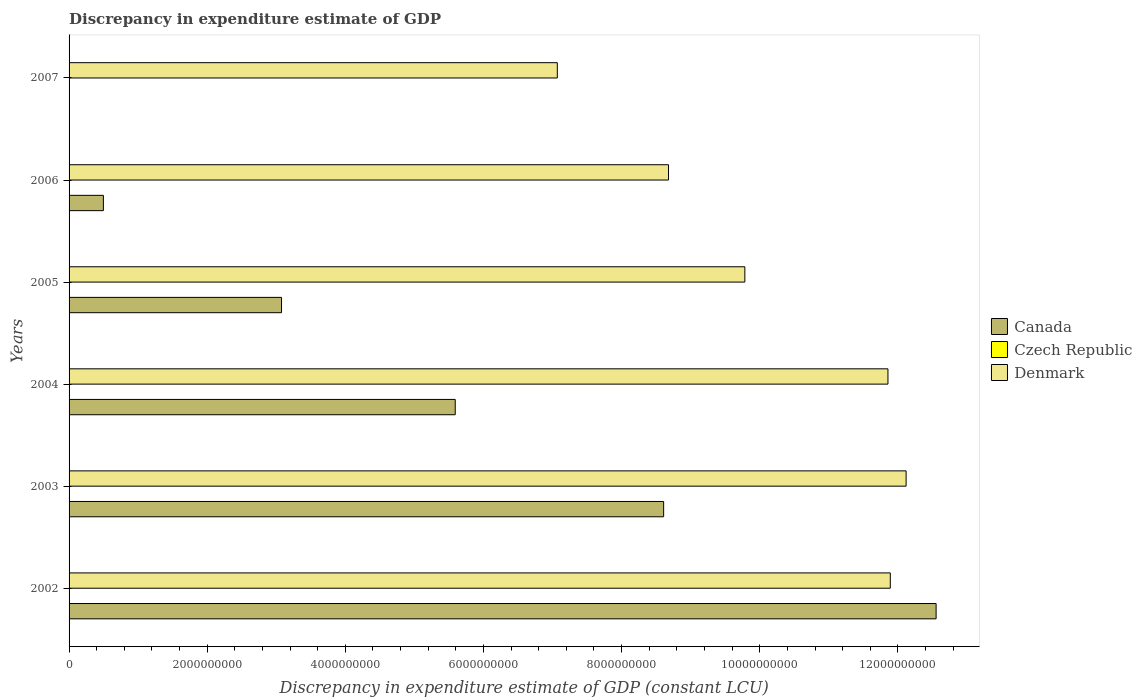Are the number of bars per tick equal to the number of legend labels?
Your answer should be compact. No. Are the number of bars on each tick of the Y-axis equal?
Ensure brevity in your answer.  No. How many bars are there on the 1st tick from the top?
Offer a very short reply. 1. What is the label of the 2nd group of bars from the top?
Provide a short and direct response. 2006. In how many cases, is the number of bars for a given year not equal to the number of legend labels?
Your response must be concise. 6. What is the discrepancy in expenditure estimate of GDP in Denmark in 2007?
Make the answer very short. 7.07e+09. Across all years, what is the maximum discrepancy in expenditure estimate of GDP in Denmark?
Provide a succinct answer. 1.21e+1. Across all years, what is the minimum discrepancy in expenditure estimate of GDP in Denmark?
Keep it short and to the point. 7.07e+09. What is the total discrepancy in expenditure estimate of GDP in Denmark in the graph?
Ensure brevity in your answer.  6.14e+1. What is the difference between the discrepancy in expenditure estimate of GDP in Canada in 2004 and that in 2005?
Your response must be concise. 2.51e+09. What is the difference between the discrepancy in expenditure estimate of GDP in Canada in 2006 and the discrepancy in expenditure estimate of GDP in Czech Republic in 2007?
Keep it short and to the point. 4.97e+08. In the year 2002, what is the difference between the discrepancy in expenditure estimate of GDP in Denmark and discrepancy in expenditure estimate of GDP in Canada?
Ensure brevity in your answer.  -6.63e+08. In how many years, is the discrepancy in expenditure estimate of GDP in Canada greater than 2000000000 LCU?
Your answer should be very brief. 4. What is the ratio of the discrepancy in expenditure estimate of GDP in Denmark in 2003 to that in 2004?
Provide a short and direct response. 1.02. Is the difference between the discrepancy in expenditure estimate of GDP in Denmark in 2002 and 2006 greater than the difference between the discrepancy in expenditure estimate of GDP in Canada in 2002 and 2006?
Provide a short and direct response. No. What is the difference between the highest and the second highest discrepancy in expenditure estimate of GDP in Denmark?
Keep it short and to the point. 2.29e+08. What is the difference between the highest and the lowest discrepancy in expenditure estimate of GDP in Canada?
Ensure brevity in your answer.  1.26e+1. Is it the case that in every year, the sum of the discrepancy in expenditure estimate of GDP in Denmark and discrepancy in expenditure estimate of GDP in Canada is greater than the discrepancy in expenditure estimate of GDP in Czech Republic?
Your answer should be very brief. Yes. How many bars are there?
Provide a short and direct response. 11. How many years are there in the graph?
Provide a succinct answer. 6. What is the difference between two consecutive major ticks on the X-axis?
Offer a terse response. 2.00e+09. Are the values on the major ticks of X-axis written in scientific E-notation?
Provide a succinct answer. No. Does the graph contain any zero values?
Ensure brevity in your answer.  Yes. Where does the legend appear in the graph?
Your answer should be compact. Center right. How many legend labels are there?
Give a very brief answer. 3. What is the title of the graph?
Your answer should be very brief. Discrepancy in expenditure estimate of GDP. Does "Afghanistan" appear as one of the legend labels in the graph?
Provide a succinct answer. No. What is the label or title of the X-axis?
Give a very brief answer. Discrepancy in expenditure estimate of GDP (constant LCU). What is the Discrepancy in expenditure estimate of GDP (constant LCU) of Canada in 2002?
Your answer should be compact. 1.26e+1. What is the Discrepancy in expenditure estimate of GDP (constant LCU) of Czech Republic in 2002?
Your answer should be very brief. 0. What is the Discrepancy in expenditure estimate of GDP (constant LCU) in Denmark in 2002?
Provide a succinct answer. 1.19e+1. What is the Discrepancy in expenditure estimate of GDP (constant LCU) in Canada in 2003?
Provide a short and direct response. 8.61e+09. What is the Discrepancy in expenditure estimate of GDP (constant LCU) in Denmark in 2003?
Offer a very short reply. 1.21e+1. What is the Discrepancy in expenditure estimate of GDP (constant LCU) in Canada in 2004?
Your response must be concise. 5.59e+09. What is the Discrepancy in expenditure estimate of GDP (constant LCU) of Denmark in 2004?
Offer a very short reply. 1.19e+1. What is the Discrepancy in expenditure estimate of GDP (constant LCU) in Canada in 2005?
Provide a short and direct response. 3.08e+09. What is the Discrepancy in expenditure estimate of GDP (constant LCU) in Denmark in 2005?
Your response must be concise. 9.78e+09. What is the Discrepancy in expenditure estimate of GDP (constant LCU) in Canada in 2006?
Offer a very short reply. 4.97e+08. What is the Discrepancy in expenditure estimate of GDP (constant LCU) of Czech Republic in 2006?
Offer a very short reply. 0. What is the Discrepancy in expenditure estimate of GDP (constant LCU) in Denmark in 2006?
Provide a short and direct response. 8.68e+09. What is the Discrepancy in expenditure estimate of GDP (constant LCU) of Canada in 2007?
Offer a terse response. 0. What is the Discrepancy in expenditure estimate of GDP (constant LCU) in Denmark in 2007?
Ensure brevity in your answer.  7.07e+09. Across all years, what is the maximum Discrepancy in expenditure estimate of GDP (constant LCU) of Canada?
Provide a succinct answer. 1.26e+1. Across all years, what is the maximum Discrepancy in expenditure estimate of GDP (constant LCU) of Denmark?
Give a very brief answer. 1.21e+1. Across all years, what is the minimum Discrepancy in expenditure estimate of GDP (constant LCU) in Canada?
Your answer should be very brief. 0. Across all years, what is the minimum Discrepancy in expenditure estimate of GDP (constant LCU) of Denmark?
Offer a very short reply. 7.07e+09. What is the total Discrepancy in expenditure estimate of GDP (constant LCU) of Canada in the graph?
Provide a succinct answer. 3.03e+1. What is the total Discrepancy in expenditure estimate of GDP (constant LCU) of Czech Republic in the graph?
Give a very brief answer. 0. What is the total Discrepancy in expenditure estimate of GDP (constant LCU) in Denmark in the graph?
Make the answer very short. 6.14e+1. What is the difference between the Discrepancy in expenditure estimate of GDP (constant LCU) of Canada in 2002 and that in 2003?
Make the answer very short. 3.94e+09. What is the difference between the Discrepancy in expenditure estimate of GDP (constant LCU) of Denmark in 2002 and that in 2003?
Ensure brevity in your answer.  -2.29e+08. What is the difference between the Discrepancy in expenditure estimate of GDP (constant LCU) of Canada in 2002 and that in 2004?
Make the answer very short. 6.96e+09. What is the difference between the Discrepancy in expenditure estimate of GDP (constant LCU) in Denmark in 2002 and that in 2004?
Keep it short and to the point. 3.40e+07. What is the difference between the Discrepancy in expenditure estimate of GDP (constant LCU) of Canada in 2002 and that in 2005?
Give a very brief answer. 9.48e+09. What is the difference between the Discrepancy in expenditure estimate of GDP (constant LCU) of Denmark in 2002 and that in 2005?
Your response must be concise. 2.11e+09. What is the difference between the Discrepancy in expenditure estimate of GDP (constant LCU) in Canada in 2002 and that in 2006?
Make the answer very short. 1.21e+1. What is the difference between the Discrepancy in expenditure estimate of GDP (constant LCU) in Denmark in 2002 and that in 2006?
Your answer should be compact. 3.21e+09. What is the difference between the Discrepancy in expenditure estimate of GDP (constant LCU) of Denmark in 2002 and that in 2007?
Your answer should be very brief. 4.82e+09. What is the difference between the Discrepancy in expenditure estimate of GDP (constant LCU) in Canada in 2003 and that in 2004?
Make the answer very short. 3.02e+09. What is the difference between the Discrepancy in expenditure estimate of GDP (constant LCU) in Denmark in 2003 and that in 2004?
Provide a short and direct response. 2.63e+08. What is the difference between the Discrepancy in expenditure estimate of GDP (constant LCU) in Canada in 2003 and that in 2005?
Ensure brevity in your answer.  5.53e+09. What is the difference between the Discrepancy in expenditure estimate of GDP (constant LCU) of Denmark in 2003 and that in 2005?
Your answer should be very brief. 2.34e+09. What is the difference between the Discrepancy in expenditure estimate of GDP (constant LCU) of Canada in 2003 and that in 2006?
Ensure brevity in your answer.  8.11e+09. What is the difference between the Discrepancy in expenditure estimate of GDP (constant LCU) in Denmark in 2003 and that in 2006?
Ensure brevity in your answer.  3.44e+09. What is the difference between the Discrepancy in expenditure estimate of GDP (constant LCU) of Denmark in 2003 and that in 2007?
Give a very brief answer. 5.05e+09. What is the difference between the Discrepancy in expenditure estimate of GDP (constant LCU) of Canada in 2004 and that in 2005?
Keep it short and to the point. 2.51e+09. What is the difference between the Discrepancy in expenditure estimate of GDP (constant LCU) of Denmark in 2004 and that in 2005?
Your answer should be compact. 2.07e+09. What is the difference between the Discrepancy in expenditure estimate of GDP (constant LCU) in Canada in 2004 and that in 2006?
Offer a very short reply. 5.09e+09. What is the difference between the Discrepancy in expenditure estimate of GDP (constant LCU) of Denmark in 2004 and that in 2006?
Keep it short and to the point. 3.18e+09. What is the difference between the Discrepancy in expenditure estimate of GDP (constant LCU) in Denmark in 2004 and that in 2007?
Provide a short and direct response. 4.79e+09. What is the difference between the Discrepancy in expenditure estimate of GDP (constant LCU) in Canada in 2005 and that in 2006?
Your answer should be very brief. 2.58e+09. What is the difference between the Discrepancy in expenditure estimate of GDP (constant LCU) in Denmark in 2005 and that in 2006?
Ensure brevity in your answer.  1.10e+09. What is the difference between the Discrepancy in expenditure estimate of GDP (constant LCU) of Denmark in 2005 and that in 2007?
Ensure brevity in your answer.  2.72e+09. What is the difference between the Discrepancy in expenditure estimate of GDP (constant LCU) of Denmark in 2006 and that in 2007?
Provide a succinct answer. 1.61e+09. What is the difference between the Discrepancy in expenditure estimate of GDP (constant LCU) in Canada in 2002 and the Discrepancy in expenditure estimate of GDP (constant LCU) in Denmark in 2003?
Offer a very short reply. 4.34e+08. What is the difference between the Discrepancy in expenditure estimate of GDP (constant LCU) of Canada in 2002 and the Discrepancy in expenditure estimate of GDP (constant LCU) of Denmark in 2004?
Keep it short and to the point. 6.97e+08. What is the difference between the Discrepancy in expenditure estimate of GDP (constant LCU) in Canada in 2002 and the Discrepancy in expenditure estimate of GDP (constant LCU) in Denmark in 2005?
Offer a very short reply. 2.77e+09. What is the difference between the Discrepancy in expenditure estimate of GDP (constant LCU) of Canada in 2002 and the Discrepancy in expenditure estimate of GDP (constant LCU) of Denmark in 2006?
Your answer should be compact. 3.87e+09. What is the difference between the Discrepancy in expenditure estimate of GDP (constant LCU) in Canada in 2002 and the Discrepancy in expenditure estimate of GDP (constant LCU) in Denmark in 2007?
Offer a terse response. 5.48e+09. What is the difference between the Discrepancy in expenditure estimate of GDP (constant LCU) of Canada in 2003 and the Discrepancy in expenditure estimate of GDP (constant LCU) of Denmark in 2004?
Offer a terse response. -3.25e+09. What is the difference between the Discrepancy in expenditure estimate of GDP (constant LCU) of Canada in 2003 and the Discrepancy in expenditure estimate of GDP (constant LCU) of Denmark in 2005?
Your response must be concise. -1.18e+09. What is the difference between the Discrepancy in expenditure estimate of GDP (constant LCU) of Canada in 2003 and the Discrepancy in expenditure estimate of GDP (constant LCU) of Denmark in 2006?
Ensure brevity in your answer.  -7.06e+07. What is the difference between the Discrepancy in expenditure estimate of GDP (constant LCU) in Canada in 2003 and the Discrepancy in expenditure estimate of GDP (constant LCU) in Denmark in 2007?
Make the answer very short. 1.54e+09. What is the difference between the Discrepancy in expenditure estimate of GDP (constant LCU) in Canada in 2004 and the Discrepancy in expenditure estimate of GDP (constant LCU) in Denmark in 2005?
Provide a short and direct response. -4.19e+09. What is the difference between the Discrepancy in expenditure estimate of GDP (constant LCU) of Canada in 2004 and the Discrepancy in expenditure estimate of GDP (constant LCU) of Denmark in 2006?
Give a very brief answer. -3.09e+09. What is the difference between the Discrepancy in expenditure estimate of GDP (constant LCU) of Canada in 2004 and the Discrepancy in expenditure estimate of GDP (constant LCU) of Denmark in 2007?
Make the answer very short. -1.48e+09. What is the difference between the Discrepancy in expenditure estimate of GDP (constant LCU) in Canada in 2005 and the Discrepancy in expenditure estimate of GDP (constant LCU) in Denmark in 2006?
Ensure brevity in your answer.  -5.60e+09. What is the difference between the Discrepancy in expenditure estimate of GDP (constant LCU) in Canada in 2005 and the Discrepancy in expenditure estimate of GDP (constant LCU) in Denmark in 2007?
Ensure brevity in your answer.  -3.99e+09. What is the difference between the Discrepancy in expenditure estimate of GDP (constant LCU) in Canada in 2006 and the Discrepancy in expenditure estimate of GDP (constant LCU) in Denmark in 2007?
Give a very brief answer. -6.57e+09. What is the average Discrepancy in expenditure estimate of GDP (constant LCU) of Canada per year?
Ensure brevity in your answer.  5.05e+09. What is the average Discrepancy in expenditure estimate of GDP (constant LCU) in Czech Republic per year?
Your answer should be compact. 0. What is the average Discrepancy in expenditure estimate of GDP (constant LCU) in Denmark per year?
Provide a short and direct response. 1.02e+1. In the year 2002, what is the difference between the Discrepancy in expenditure estimate of GDP (constant LCU) in Canada and Discrepancy in expenditure estimate of GDP (constant LCU) in Denmark?
Provide a short and direct response. 6.63e+08. In the year 2003, what is the difference between the Discrepancy in expenditure estimate of GDP (constant LCU) of Canada and Discrepancy in expenditure estimate of GDP (constant LCU) of Denmark?
Your response must be concise. -3.51e+09. In the year 2004, what is the difference between the Discrepancy in expenditure estimate of GDP (constant LCU) of Canada and Discrepancy in expenditure estimate of GDP (constant LCU) of Denmark?
Provide a short and direct response. -6.27e+09. In the year 2005, what is the difference between the Discrepancy in expenditure estimate of GDP (constant LCU) in Canada and Discrepancy in expenditure estimate of GDP (constant LCU) in Denmark?
Offer a very short reply. -6.71e+09. In the year 2006, what is the difference between the Discrepancy in expenditure estimate of GDP (constant LCU) in Canada and Discrepancy in expenditure estimate of GDP (constant LCU) in Denmark?
Your response must be concise. -8.18e+09. What is the ratio of the Discrepancy in expenditure estimate of GDP (constant LCU) in Canada in 2002 to that in 2003?
Ensure brevity in your answer.  1.46. What is the ratio of the Discrepancy in expenditure estimate of GDP (constant LCU) of Denmark in 2002 to that in 2003?
Make the answer very short. 0.98. What is the ratio of the Discrepancy in expenditure estimate of GDP (constant LCU) in Canada in 2002 to that in 2004?
Your answer should be very brief. 2.25. What is the ratio of the Discrepancy in expenditure estimate of GDP (constant LCU) of Denmark in 2002 to that in 2004?
Ensure brevity in your answer.  1. What is the ratio of the Discrepancy in expenditure estimate of GDP (constant LCU) of Canada in 2002 to that in 2005?
Ensure brevity in your answer.  4.08. What is the ratio of the Discrepancy in expenditure estimate of GDP (constant LCU) of Denmark in 2002 to that in 2005?
Your response must be concise. 1.22. What is the ratio of the Discrepancy in expenditure estimate of GDP (constant LCU) in Canada in 2002 to that in 2006?
Provide a short and direct response. 25.26. What is the ratio of the Discrepancy in expenditure estimate of GDP (constant LCU) of Denmark in 2002 to that in 2006?
Provide a succinct answer. 1.37. What is the ratio of the Discrepancy in expenditure estimate of GDP (constant LCU) of Denmark in 2002 to that in 2007?
Offer a terse response. 1.68. What is the ratio of the Discrepancy in expenditure estimate of GDP (constant LCU) of Canada in 2003 to that in 2004?
Keep it short and to the point. 1.54. What is the ratio of the Discrepancy in expenditure estimate of GDP (constant LCU) of Denmark in 2003 to that in 2004?
Provide a short and direct response. 1.02. What is the ratio of the Discrepancy in expenditure estimate of GDP (constant LCU) of Canada in 2003 to that in 2005?
Your answer should be compact. 2.8. What is the ratio of the Discrepancy in expenditure estimate of GDP (constant LCU) of Denmark in 2003 to that in 2005?
Offer a terse response. 1.24. What is the ratio of the Discrepancy in expenditure estimate of GDP (constant LCU) in Canada in 2003 to that in 2006?
Offer a very short reply. 17.32. What is the ratio of the Discrepancy in expenditure estimate of GDP (constant LCU) of Denmark in 2003 to that in 2006?
Ensure brevity in your answer.  1.4. What is the ratio of the Discrepancy in expenditure estimate of GDP (constant LCU) of Denmark in 2003 to that in 2007?
Your response must be concise. 1.71. What is the ratio of the Discrepancy in expenditure estimate of GDP (constant LCU) of Canada in 2004 to that in 2005?
Offer a very short reply. 1.82. What is the ratio of the Discrepancy in expenditure estimate of GDP (constant LCU) of Denmark in 2004 to that in 2005?
Offer a very short reply. 1.21. What is the ratio of the Discrepancy in expenditure estimate of GDP (constant LCU) of Canada in 2004 to that in 2006?
Your answer should be compact. 11.25. What is the ratio of the Discrepancy in expenditure estimate of GDP (constant LCU) of Denmark in 2004 to that in 2006?
Provide a short and direct response. 1.37. What is the ratio of the Discrepancy in expenditure estimate of GDP (constant LCU) in Denmark in 2004 to that in 2007?
Your answer should be very brief. 1.68. What is the ratio of the Discrepancy in expenditure estimate of GDP (constant LCU) in Canada in 2005 to that in 2006?
Give a very brief answer. 6.19. What is the ratio of the Discrepancy in expenditure estimate of GDP (constant LCU) of Denmark in 2005 to that in 2006?
Provide a short and direct response. 1.13. What is the ratio of the Discrepancy in expenditure estimate of GDP (constant LCU) in Denmark in 2005 to that in 2007?
Offer a terse response. 1.38. What is the ratio of the Discrepancy in expenditure estimate of GDP (constant LCU) of Denmark in 2006 to that in 2007?
Give a very brief answer. 1.23. What is the difference between the highest and the second highest Discrepancy in expenditure estimate of GDP (constant LCU) of Canada?
Ensure brevity in your answer.  3.94e+09. What is the difference between the highest and the second highest Discrepancy in expenditure estimate of GDP (constant LCU) of Denmark?
Your answer should be compact. 2.29e+08. What is the difference between the highest and the lowest Discrepancy in expenditure estimate of GDP (constant LCU) of Canada?
Make the answer very short. 1.26e+1. What is the difference between the highest and the lowest Discrepancy in expenditure estimate of GDP (constant LCU) of Denmark?
Make the answer very short. 5.05e+09. 